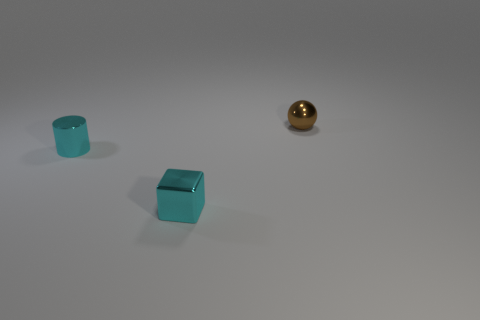Add 3 tiny cyan cubes. How many objects exist? 6 Subtract all cylinders. How many objects are left? 2 Add 3 small matte cylinders. How many small matte cylinders exist? 3 Subtract 0 green blocks. How many objects are left? 3 Subtract all large gray rubber objects. Subtract all metal things. How many objects are left? 0 Add 1 cyan shiny blocks. How many cyan shiny blocks are left? 2 